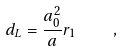Convert formula to latex. <formula><loc_0><loc_0><loc_500><loc_500>d _ { L } = \frac { a _ { 0 } ^ { 2 } } { a } r _ { 1 } \quad ,</formula> 